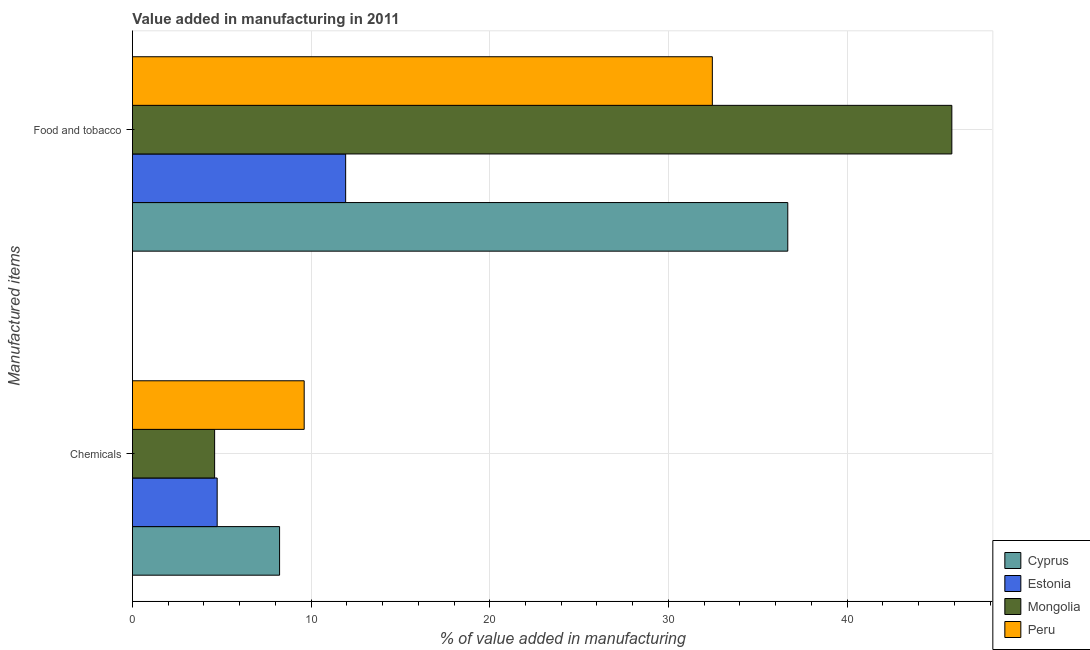How many different coloured bars are there?
Your answer should be very brief. 4. Are the number of bars per tick equal to the number of legend labels?
Offer a terse response. Yes. Are the number of bars on each tick of the Y-axis equal?
Provide a succinct answer. Yes. How many bars are there on the 1st tick from the top?
Provide a short and direct response. 4. What is the label of the 1st group of bars from the top?
Provide a short and direct response. Food and tobacco. What is the value added by manufacturing food and tobacco in Mongolia?
Provide a short and direct response. 45.86. Across all countries, what is the maximum value added by manufacturing food and tobacco?
Provide a succinct answer. 45.86. Across all countries, what is the minimum value added by  manufacturing chemicals?
Your response must be concise. 4.6. In which country was the value added by  manufacturing chemicals maximum?
Provide a succinct answer. Peru. In which country was the value added by  manufacturing chemicals minimum?
Ensure brevity in your answer.  Mongolia. What is the total value added by manufacturing food and tobacco in the graph?
Provide a succinct answer. 126.93. What is the difference between the value added by manufacturing food and tobacco in Cyprus and that in Estonia?
Offer a terse response. 24.74. What is the difference between the value added by  manufacturing chemicals in Mongolia and the value added by manufacturing food and tobacco in Peru?
Offer a very short reply. -27.86. What is the average value added by  manufacturing chemicals per country?
Ensure brevity in your answer.  6.8. What is the difference between the value added by  manufacturing chemicals and value added by manufacturing food and tobacco in Estonia?
Your answer should be very brief. -7.19. What is the ratio of the value added by  manufacturing chemicals in Peru to that in Mongolia?
Ensure brevity in your answer.  2.09. Is the value added by manufacturing food and tobacco in Estonia less than that in Cyprus?
Your answer should be compact. Yes. What does the 1st bar from the top in Food and tobacco represents?
Provide a succinct answer. Peru. What does the 3rd bar from the bottom in Food and tobacco represents?
Provide a short and direct response. Mongolia. How many bars are there?
Ensure brevity in your answer.  8. How many countries are there in the graph?
Provide a succinct answer. 4. What is the difference between two consecutive major ticks on the X-axis?
Your response must be concise. 10. Does the graph contain grids?
Your answer should be compact. Yes. How many legend labels are there?
Offer a very short reply. 4. What is the title of the graph?
Ensure brevity in your answer.  Value added in manufacturing in 2011. Does "Andorra" appear as one of the legend labels in the graph?
Your answer should be compact. No. What is the label or title of the X-axis?
Make the answer very short. % of value added in manufacturing. What is the label or title of the Y-axis?
Keep it short and to the point. Manufactured items. What is the % of value added in manufacturing in Cyprus in Chemicals?
Provide a short and direct response. 8.24. What is the % of value added in manufacturing in Estonia in Chemicals?
Offer a very short reply. 4.74. What is the % of value added in manufacturing in Mongolia in Chemicals?
Ensure brevity in your answer.  4.6. What is the % of value added in manufacturing of Peru in Chemicals?
Provide a short and direct response. 9.61. What is the % of value added in manufacturing of Cyprus in Food and tobacco?
Ensure brevity in your answer.  36.68. What is the % of value added in manufacturing of Estonia in Food and tobacco?
Make the answer very short. 11.93. What is the % of value added in manufacturing of Mongolia in Food and tobacco?
Ensure brevity in your answer.  45.86. What is the % of value added in manufacturing of Peru in Food and tobacco?
Make the answer very short. 32.46. Across all Manufactured items, what is the maximum % of value added in manufacturing of Cyprus?
Your response must be concise. 36.68. Across all Manufactured items, what is the maximum % of value added in manufacturing of Estonia?
Offer a very short reply. 11.93. Across all Manufactured items, what is the maximum % of value added in manufacturing in Mongolia?
Provide a succinct answer. 45.86. Across all Manufactured items, what is the maximum % of value added in manufacturing of Peru?
Provide a succinct answer. 32.46. Across all Manufactured items, what is the minimum % of value added in manufacturing in Cyprus?
Make the answer very short. 8.24. Across all Manufactured items, what is the minimum % of value added in manufacturing in Estonia?
Give a very brief answer. 4.74. Across all Manufactured items, what is the minimum % of value added in manufacturing in Mongolia?
Make the answer very short. 4.6. Across all Manufactured items, what is the minimum % of value added in manufacturing of Peru?
Your response must be concise. 9.61. What is the total % of value added in manufacturing of Cyprus in the graph?
Make the answer very short. 44.91. What is the total % of value added in manufacturing of Estonia in the graph?
Keep it short and to the point. 16.68. What is the total % of value added in manufacturing in Mongolia in the graph?
Your answer should be compact. 50.46. What is the total % of value added in manufacturing in Peru in the graph?
Offer a very short reply. 42.07. What is the difference between the % of value added in manufacturing in Cyprus in Chemicals and that in Food and tobacco?
Ensure brevity in your answer.  -28.44. What is the difference between the % of value added in manufacturing of Estonia in Chemicals and that in Food and tobacco?
Your response must be concise. -7.19. What is the difference between the % of value added in manufacturing of Mongolia in Chemicals and that in Food and tobacco?
Provide a succinct answer. -41.26. What is the difference between the % of value added in manufacturing in Peru in Chemicals and that in Food and tobacco?
Give a very brief answer. -22.84. What is the difference between the % of value added in manufacturing in Cyprus in Chemicals and the % of value added in manufacturing in Estonia in Food and tobacco?
Provide a succinct answer. -3.7. What is the difference between the % of value added in manufacturing of Cyprus in Chemicals and the % of value added in manufacturing of Mongolia in Food and tobacco?
Your answer should be very brief. -37.63. What is the difference between the % of value added in manufacturing of Cyprus in Chemicals and the % of value added in manufacturing of Peru in Food and tobacco?
Offer a terse response. -24.22. What is the difference between the % of value added in manufacturing of Estonia in Chemicals and the % of value added in manufacturing of Mongolia in Food and tobacco?
Offer a very short reply. -41.12. What is the difference between the % of value added in manufacturing of Estonia in Chemicals and the % of value added in manufacturing of Peru in Food and tobacco?
Offer a terse response. -27.71. What is the difference between the % of value added in manufacturing in Mongolia in Chemicals and the % of value added in manufacturing in Peru in Food and tobacco?
Your response must be concise. -27.86. What is the average % of value added in manufacturing in Cyprus per Manufactured items?
Offer a terse response. 22.46. What is the average % of value added in manufacturing of Estonia per Manufactured items?
Offer a terse response. 8.34. What is the average % of value added in manufacturing in Mongolia per Manufactured items?
Offer a terse response. 25.23. What is the average % of value added in manufacturing of Peru per Manufactured items?
Your answer should be compact. 21.03. What is the difference between the % of value added in manufacturing in Cyprus and % of value added in manufacturing in Estonia in Chemicals?
Your answer should be compact. 3.49. What is the difference between the % of value added in manufacturing in Cyprus and % of value added in manufacturing in Mongolia in Chemicals?
Make the answer very short. 3.63. What is the difference between the % of value added in manufacturing of Cyprus and % of value added in manufacturing of Peru in Chemicals?
Keep it short and to the point. -1.38. What is the difference between the % of value added in manufacturing in Estonia and % of value added in manufacturing in Mongolia in Chemicals?
Provide a succinct answer. 0.14. What is the difference between the % of value added in manufacturing in Estonia and % of value added in manufacturing in Peru in Chemicals?
Make the answer very short. -4.87. What is the difference between the % of value added in manufacturing of Mongolia and % of value added in manufacturing of Peru in Chemicals?
Your response must be concise. -5.01. What is the difference between the % of value added in manufacturing of Cyprus and % of value added in manufacturing of Estonia in Food and tobacco?
Give a very brief answer. 24.74. What is the difference between the % of value added in manufacturing of Cyprus and % of value added in manufacturing of Mongolia in Food and tobacco?
Keep it short and to the point. -9.18. What is the difference between the % of value added in manufacturing of Cyprus and % of value added in manufacturing of Peru in Food and tobacco?
Provide a short and direct response. 4.22. What is the difference between the % of value added in manufacturing in Estonia and % of value added in manufacturing in Mongolia in Food and tobacco?
Ensure brevity in your answer.  -33.93. What is the difference between the % of value added in manufacturing of Estonia and % of value added in manufacturing of Peru in Food and tobacco?
Offer a very short reply. -20.52. What is the difference between the % of value added in manufacturing in Mongolia and % of value added in manufacturing in Peru in Food and tobacco?
Offer a very short reply. 13.4. What is the ratio of the % of value added in manufacturing in Cyprus in Chemicals to that in Food and tobacco?
Your response must be concise. 0.22. What is the ratio of the % of value added in manufacturing in Estonia in Chemicals to that in Food and tobacco?
Your response must be concise. 0.4. What is the ratio of the % of value added in manufacturing in Mongolia in Chemicals to that in Food and tobacco?
Provide a succinct answer. 0.1. What is the ratio of the % of value added in manufacturing of Peru in Chemicals to that in Food and tobacco?
Your answer should be very brief. 0.3. What is the difference between the highest and the second highest % of value added in manufacturing in Cyprus?
Your answer should be very brief. 28.44. What is the difference between the highest and the second highest % of value added in manufacturing of Estonia?
Offer a very short reply. 7.19. What is the difference between the highest and the second highest % of value added in manufacturing in Mongolia?
Give a very brief answer. 41.26. What is the difference between the highest and the second highest % of value added in manufacturing of Peru?
Give a very brief answer. 22.84. What is the difference between the highest and the lowest % of value added in manufacturing in Cyprus?
Your answer should be very brief. 28.44. What is the difference between the highest and the lowest % of value added in manufacturing of Estonia?
Ensure brevity in your answer.  7.19. What is the difference between the highest and the lowest % of value added in manufacturing in Mongolia?
Your response must be concise. 41.26. What is the difference between the highest and the lowest % of value added in manufacturing in Peru?
Your response must be concise. 22.84. 